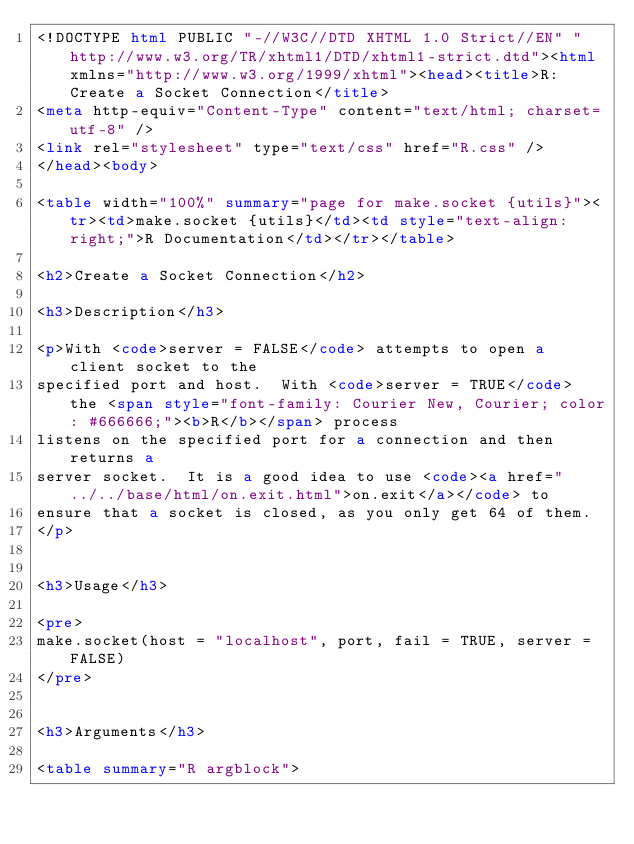Convert code to text. <code><loc_0><loc_0><loc_500><loc_500><_HTML_><!DOCTYPE html PUBLIC "-//W3C//DTD XHTML 1.0 Strict//EN" "http://www.w3.org/TR/xhtml1/DTD/xhtml1-strict.dtd"><html xmlns="http://www.w3.org/1999/xhtml"><head><title>R: Create a Socket Connection</title>
<meta http-equiv="Content-Type" content="text/html; charset=utf-8" />
<link rel="stylesheet" type="text/css" href="R.css" />
</head><body>

<table width="100%" summary="page for make.socket {utils}"><tr><td>make.socket {utils}</td><td style="text-align: right;">R Documentation</td></tr></table>

<h2>Create a Socket Connection</h2>

<h3>Description</h3>

<p>With <code>server = FALSE</code> attempts to open a client socket to the
specified port and host.  With <code>server = TRUE</code> the <span style="font-family: Courier New, Courier; color: #666666;"><b>R</b></span> process
listens on the specified port for a connection and then returns a
server socket.  It is a good idea to use <code><a href="../../base/html/on.exit.html">on.exit</a></code> to
ensure that a socket is closed, as you only get 64 of them.
</p>


<h3>Usage</h3>

<pre>
make.socket(host = "localhost", port, fail = TRUE, server = FALSE)
</pre>


<h3>Arguments</h3>

<table summary="R argblock"></code> 